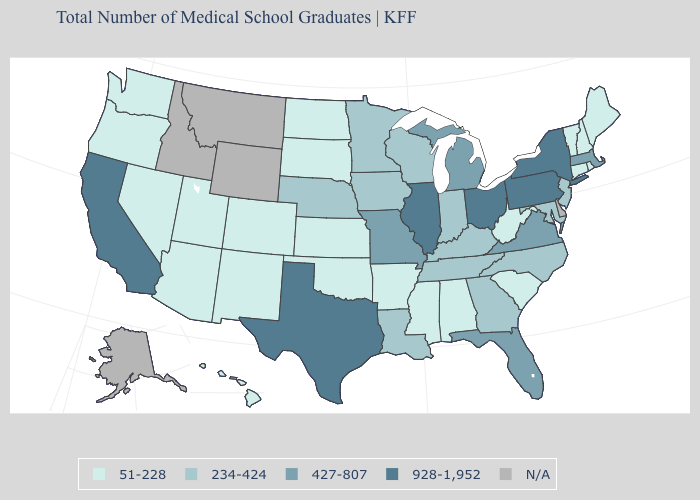Does Texas have the highest value in the South?
Short answer required. Yes. What is the value of Idaho?
Answer briefly. N/A. What is the value of Kansas?
Be succinct. 51-228. Name the states that have a value in the range N/A?
Short answer required. Alaska, Delaware, Idaho, Montana, Wyoming. What is the value of Florida?
Concise answer only. 427-807. What is the value of Idaho?
Be succinct. N/A. Does the map have missing data?
Give a very brief answer. Yes. What is the value of Alaska?
Answer briefly. N/A. What is the value of South Carolina?
Short answer required. 51-228. What is the value of Louisiana?
Concise answer only. 234-424. Name the states that have a value in the range 928-1,952?
Write a very short answer. California, Illinois, New York, Ohio, Pennsylvania, Texas. What is the value of Florida?
Keep it brief. 427-807. What is the highest value in the USA?
Short answer required. 928-1,952. Name the states that have a value in the range 234-424?
Answer briefly. Georgia, Indiana, Iowa, Kentucky, Louisiana, Maryland, Minnesota, Nebraska, New Jersey, North Carolina, Tennessee, Wisconsin. Among the states that border Washington , which have the highest value?
Write a very short answer. Oregon. 